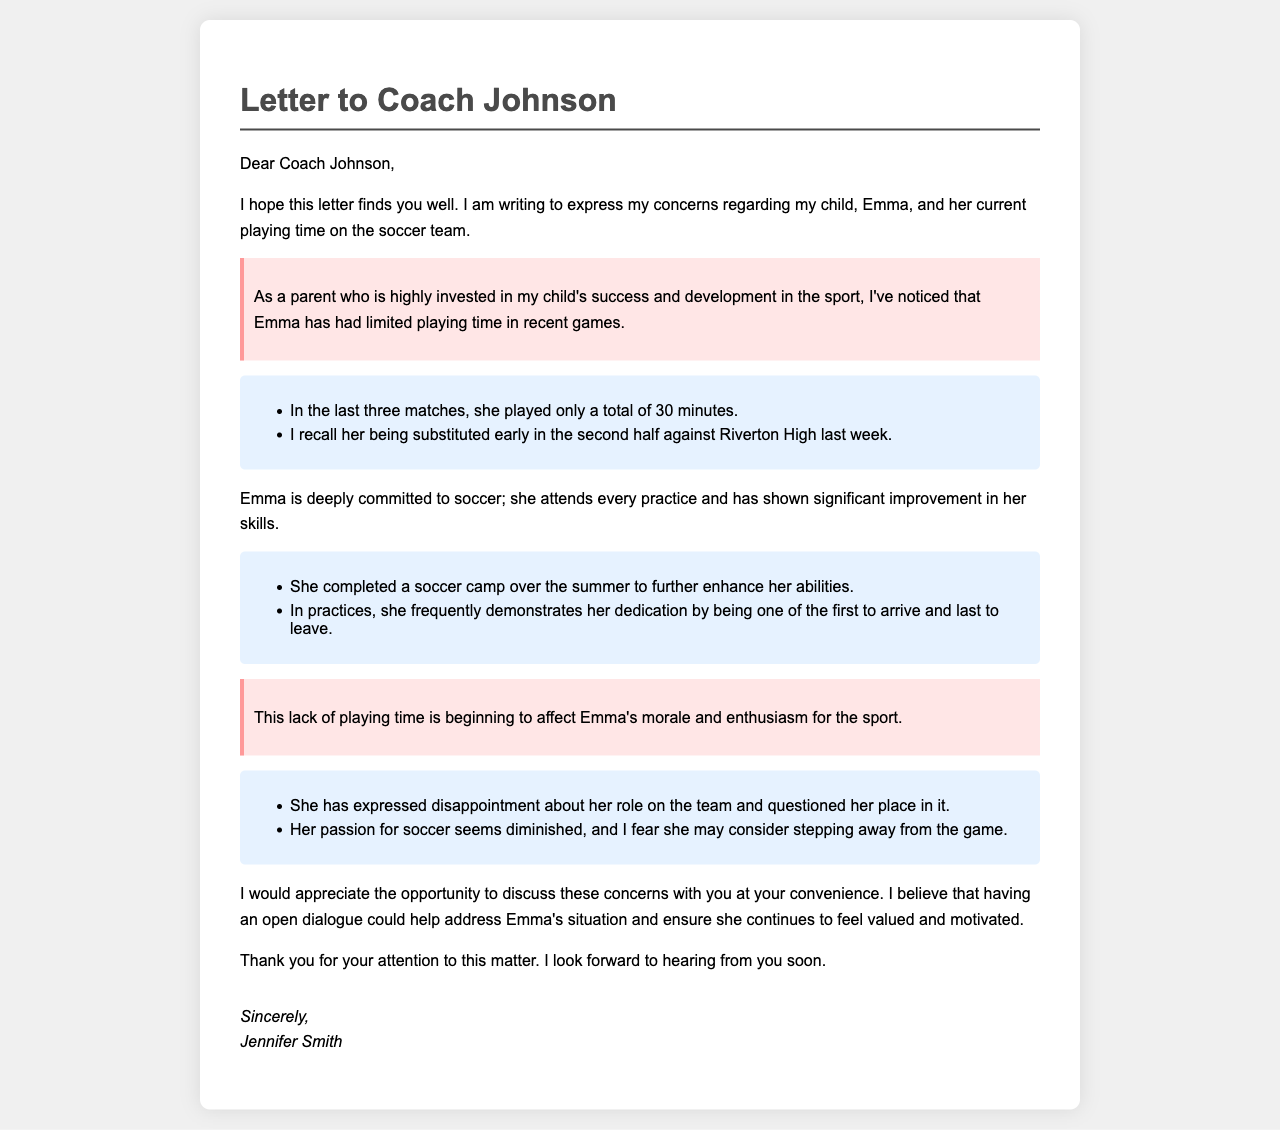What is the name of the coach addressed in the letter? The coach's name is mentioned in the salutation of the letter.
Answer: Coach Johnson What is the name of the child mentioned in the letter? The child's name is stated at the beginning where their concerns are expressed.
Answer: Emma How many minutes did Emma play in the last three matches? This information is provided in the examples section detailing her limited playing time.
Answer: 30 minutes What action did Emma take over the summer to improve her soccer skills? This is mentioned in the context of her commitment to the sport and efforts to enhance her abilities.
Answer: Completed a soccer camp What has Emma expressed about her role on the team? The letter notes her feelings regarding her position and participation in the sport.
Answer: Disappointment What is starting to affect Emma's morale and enthusiasm? The letter highlights a specific issue that impacts her feelings towards the sport.
Answer: Lack of playing time What is Jennifer Smith’s relationship to Emma? This can be inferred from the signature at the end of the letter.
Answer: Parent What does Jennifer request in her letter? The letter states a desire for future communication regarding Emma's situation.
Answer: Opportunity to discuss concerns 